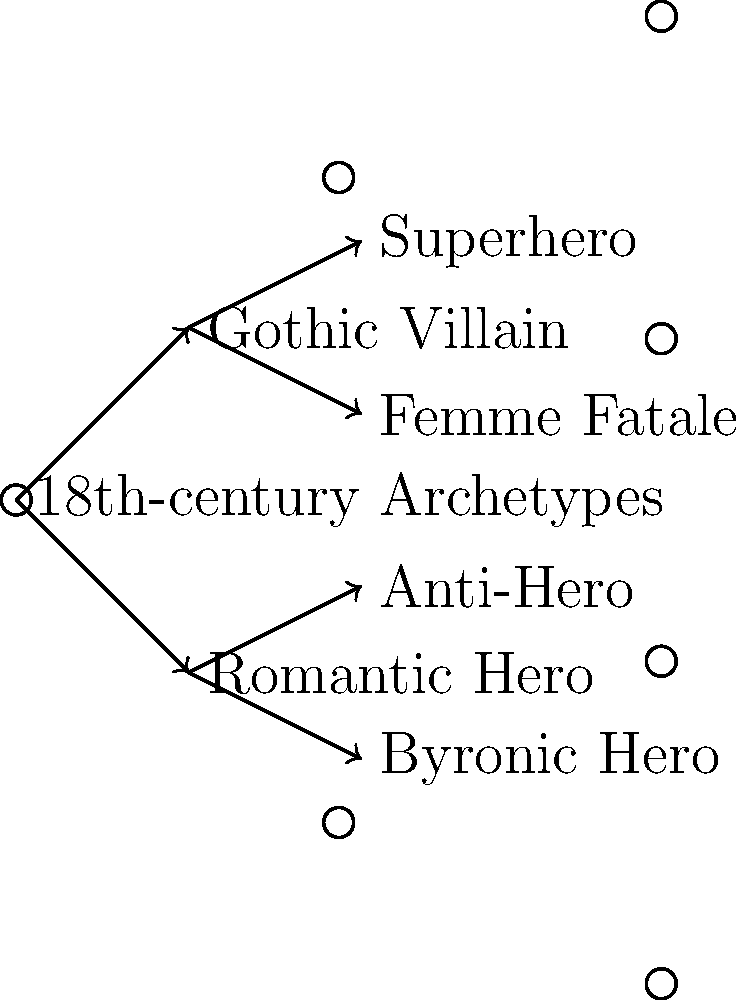Based on the branching tree diagram, which 18th-century archetype directly influenced the development of the "Femme Fatale" character in modern media? To answer this question, we need to follow these steps:

1. Identify the root node of the tree, which represents 18th-century archetypes.
2. Trace the branches from the root node to the "Femme Fatale" character.
3. Identify the immediate predecessor of the "Femme Fatale" in the tree.

Following these steps:

1. The root node is labeled "18th-century Archetypes".
2. From the root, we can see two main branches: "Romantic Hero" and "Gothic Villain".
3. The "Femme Fatale" is connected to the "Gothic Villain" branch.

Therefore, the diagram shows that the Gothic Villain archetype from 18th-century literature directly influenced the development of the Femme Fatale character in modern media.

This evolution makes sense from a literary perspective, as the Gothic genre often featured mysterious, dangerous, and seductive characters, which are qualities typically associated with the Femme Fatale archetype in contemporary media.
Answer: Gothic Villain 